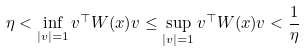Convert formula to latex. <formula><loc_0><loc_0><loc_500><loc_500>\eta < \inf _ { | v | = 1 } v ^ { \top } W ( x ) v \leq \sup _ { | v | = 1 } v ^ { \top } W ( x ) v < \frac { 1 } { \eta }</formula> 